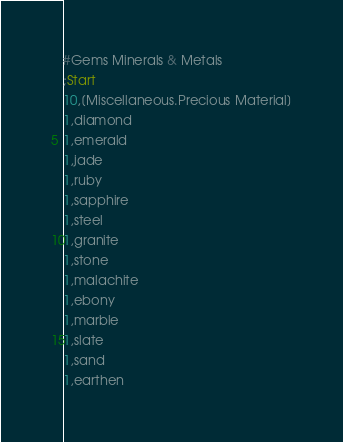<code> <loc_0><loc_0><loc_500><loc_500><_SQL_>#Gems Minerals & Metals
;Start
10,[Miscellaneous.Precious Material]
1,diamond
1,emerald
1,jade
1,ruby
1,sapphire
1,steel
1,granite
1,stone
1,malachite
1,ebony
1,marble
1,slate
1,sand
1,earthen
</code> 